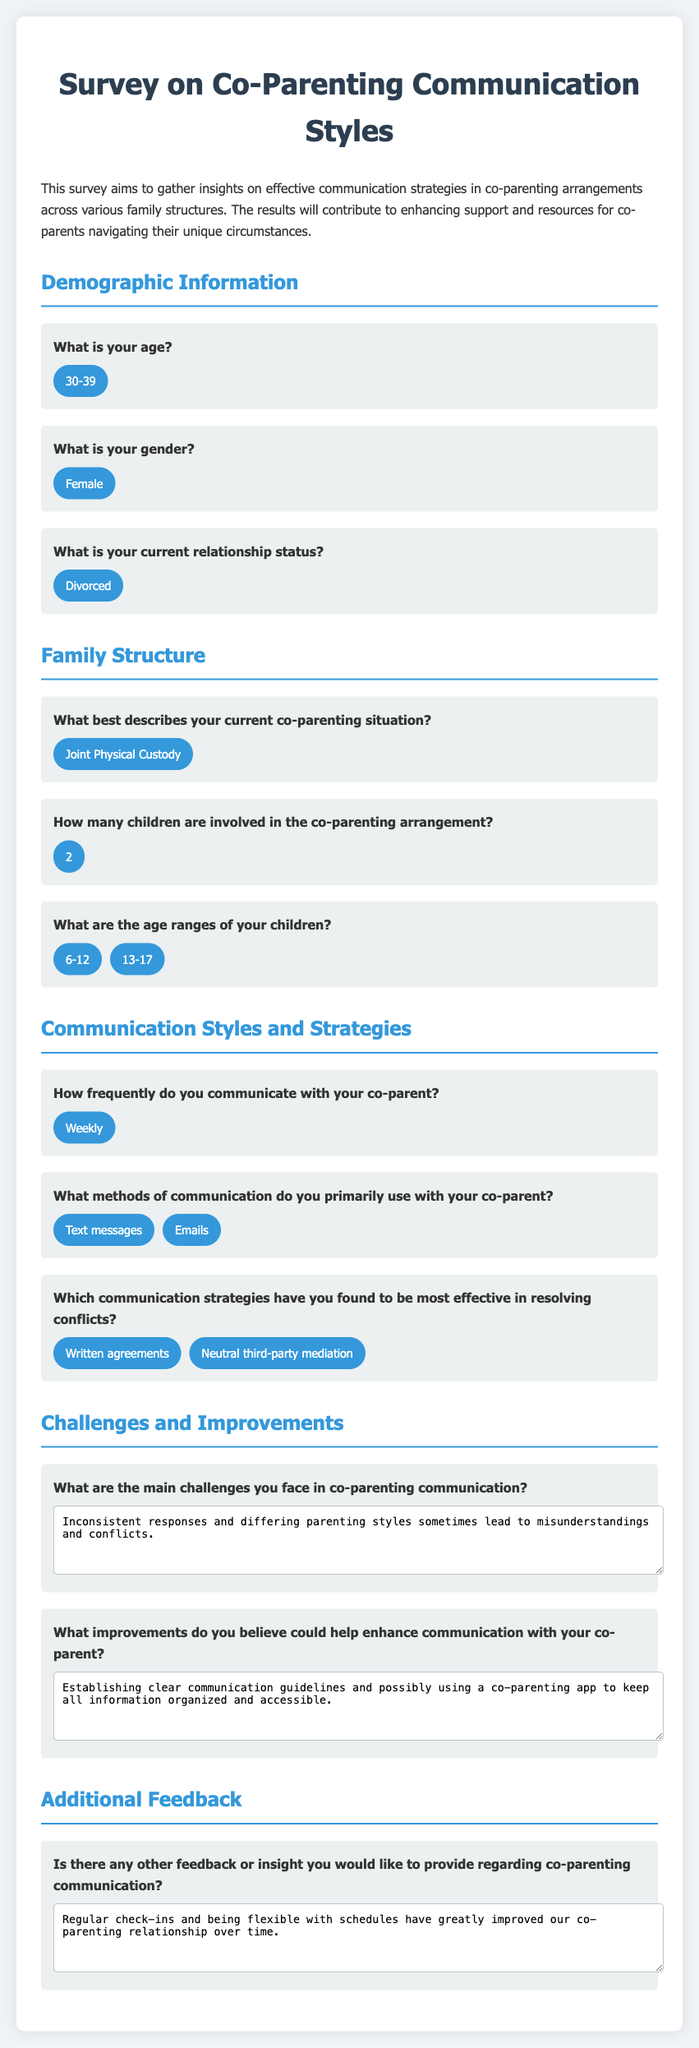What is the age range of the respondent? The document states that the respondent's age is categorized as 30-39.
Answer: 30-39 What is the gender of the respondent? The respondent's gender, as specified in the document, is Female.
Answer: Female What is the relationship status of the respondent? The document indicates that the respondent is Divorced.
Answer: Divorced How many children are involved in the co-parenting arrangement? According to the document, the respondent has 2 children in the co-parenting setup.
Answer: 2 What methods of communication do the respondents primarily use? The document mentions that the respondents primarily communicate via Text messages and Emails.
Answer: Text messages, Emails What is the frequency of communication between the co-parents? The document states that the co-parents communicate Weekly.
Answer: Weekly What are the main challenges faced in co-parenting communication? The respondent cited Inconsistent responses and differing parenting styles as main challenges according to the textarea response.
Answer: Inconsistent responses and differing parenting styles What improvements could enhance communication with the co-parent? The improvements suggested include Establishing clear communication guidelines and using a co-parenting app for organization.
Answer: Establishing clear communication guidelines, co-parenting app What were the effective strategies for resolving conflicts? The respondents find Written agreements and Neutral third-party mediation as effective strategies for conflict resolution.
Answer: Written agreements, Neutral third-party mediation What additional feedback was provided about co-parenting communication? The respondent provided insights about Regular check-ins and being flexible with schedules improving their co-parenting relationship.
Answer: Regular check-ins and being flexible with schedules 